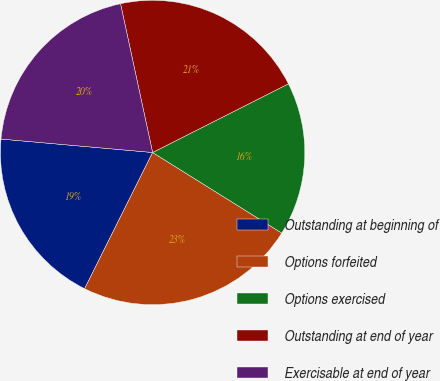Convert chart to OTSL. <chart><loc_0><loc_0><loc_500><loc_500><pie_chart><fcel>Outstanding at beginning of<fcel>Options forfeited<fcel>Options exercised<fcel>Outstanding at end of year<fcel>Exercisable at end of year<nl><fcel>19.04%<fcel>23.49%<fcel>16.33%<fcel>20.93%<fcel>20.21%<nl></chart> 